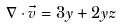Convert formula to latex. <formula><loc_0><loc_0><loc_500><loc_500>\nabla \cdot \vec { v } = 3 y + 2 y z</formula> 